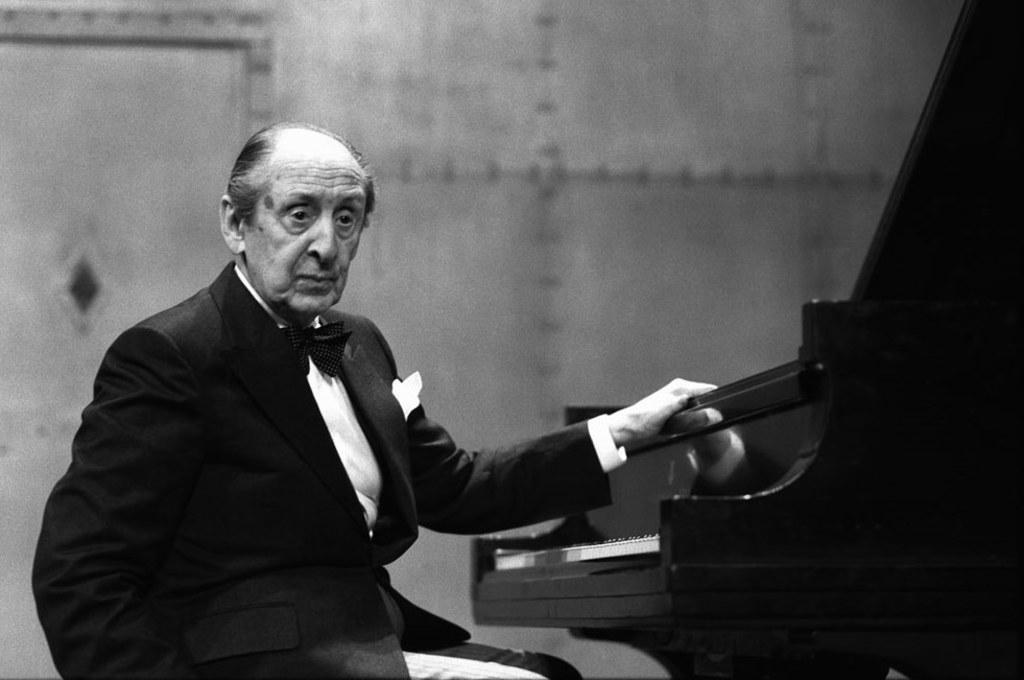Who is in the image? There is a man in the image. What is the man wearing? The man is wearing a black jacket and a white shirt. What is the man doing in the image? The man is sitting. What object is in front of the man? There is a piano in front of the man. What is the man doing with the piano? The man has his left hand on the piano. What type of throne is the man sitting on in the image? There is no throne present in the image; the man is sitting on a regular chair or bench. Can you see any insects crawling on the piano in the image? There are no insects visible in the image, and therefore no such activity can be observed. 